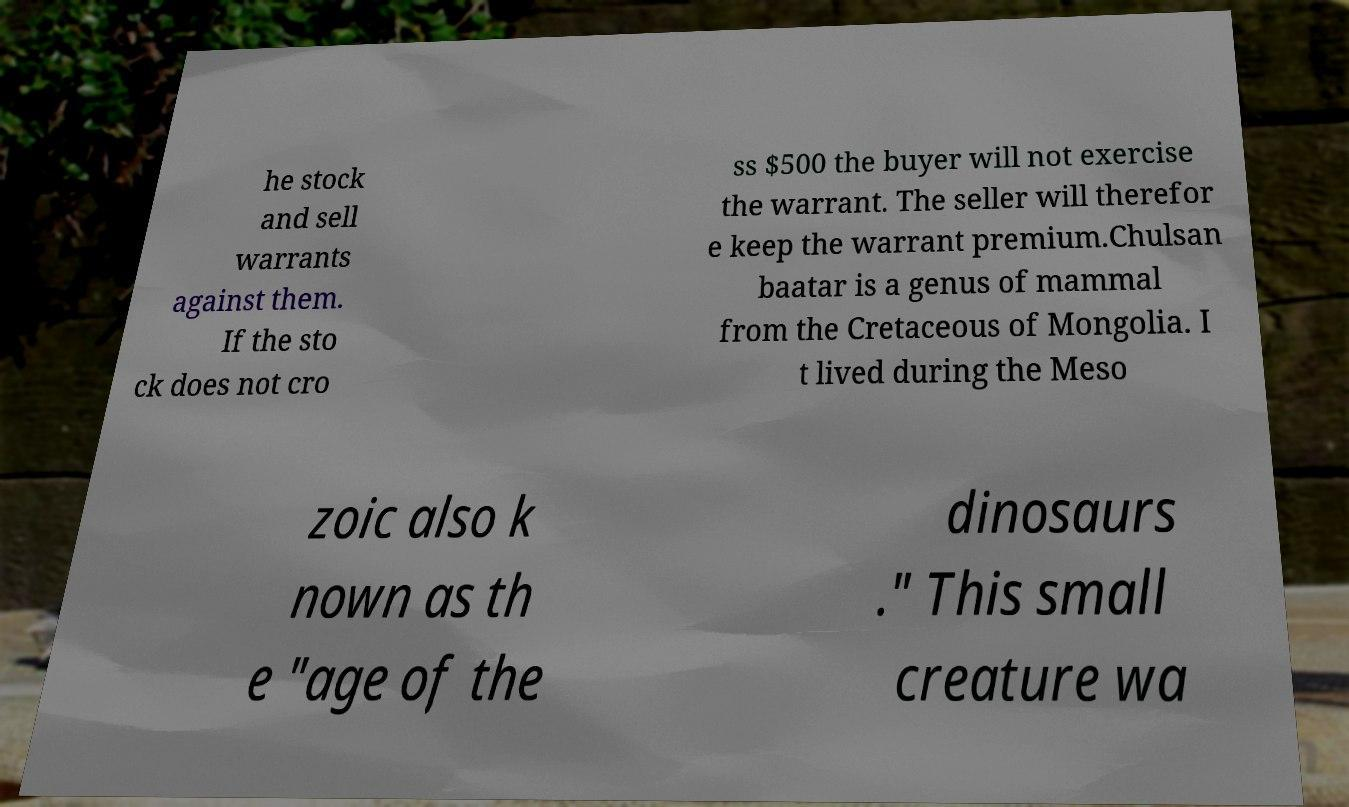For documentation purposes, I need the text within this image transcribed. Could you provide that? he stock and sell warrants against them. If the sto ck does not cro ss $500 the buyer will not exercise the warrant. The seller will therefor e keep the warrant premium.Chulsan baatar is a genus of mammal from the Cretaceous of Mongolia. I t lived during the Meso zoic also k nown as th e "age of the dinosaurs ." This small creature wa 